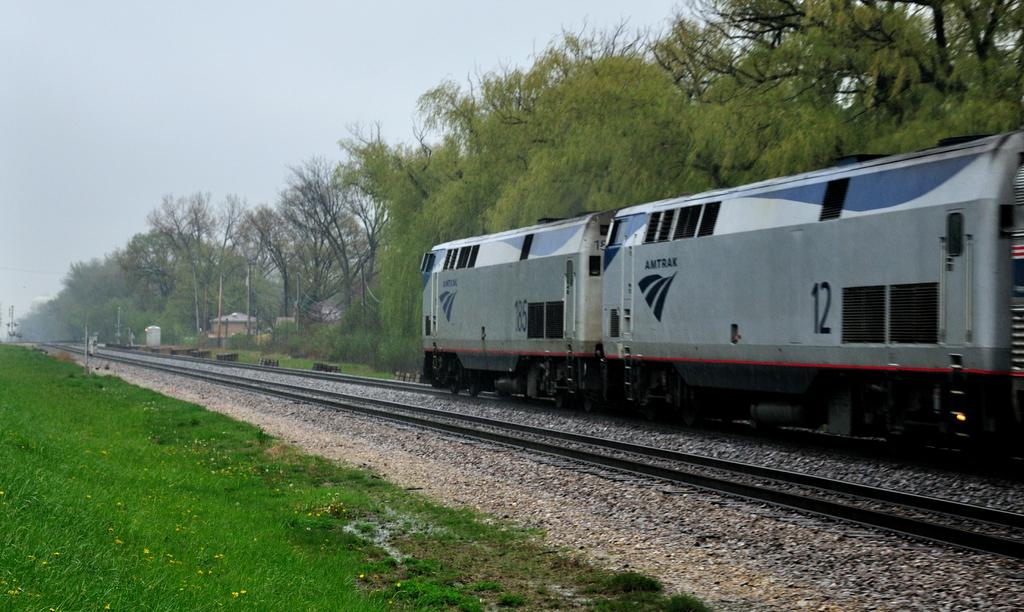What is the main subject of the image? The main subject of the image is a train. Where is the train located in the image? The train is on train tracks in the image. What type of vegetation can be seen in the image? There are trees and grass visible in the image. What else is present in the image besides the train and vegetation? Stones are present in the image. What is visible in the background of the image? The sky is visible in the image. How many trucks are parked next to the train in the image? There are no trucks present in the image; it only features a train on train tracks, surrounded by grass, trees, stones, and the sky. 